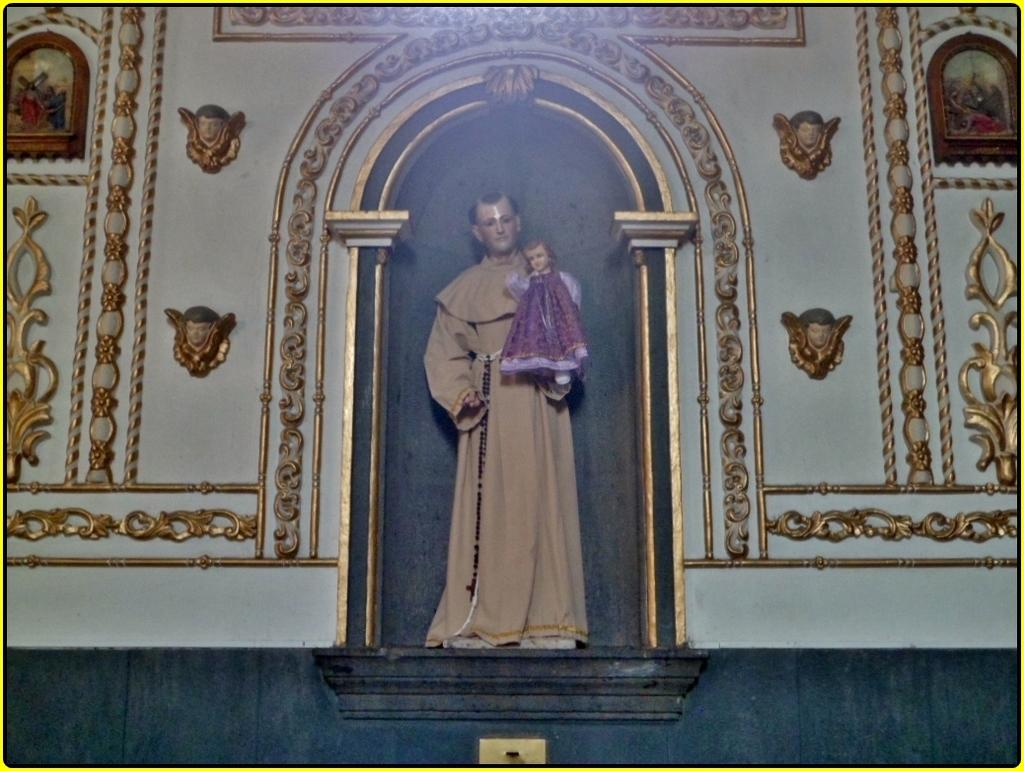What is the main subject in the image? There is a statue in the image. What type of architectural feature can be seen in the image? There is arch architecture in the image. What other design element is present in the image? There is a design wall in the image. Can you see any clouds in the image? There is no reference to clouds in the image, as it features a statue, arch architecture, and a design wall. Is there any money visible in the image? There is no money present in the image. Can you see the moon in the image? There is no moon present in the image. 